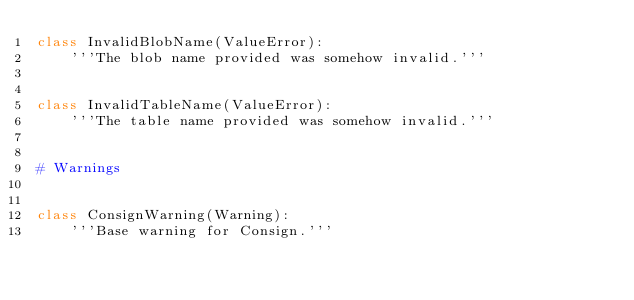<code> <loc_0><loc_0><loc_500><loc_500><_Python_>class InvalidBlobName(ValueError):
    '''The blob name provided was somehow invalid.'''


class InvalidTableName(ValueError):
    '''The table name provided was somehow invalid.'''


# Warnings


class ConsignWarning(Warning):
    '''Base warning for Consign.'''
</code> 